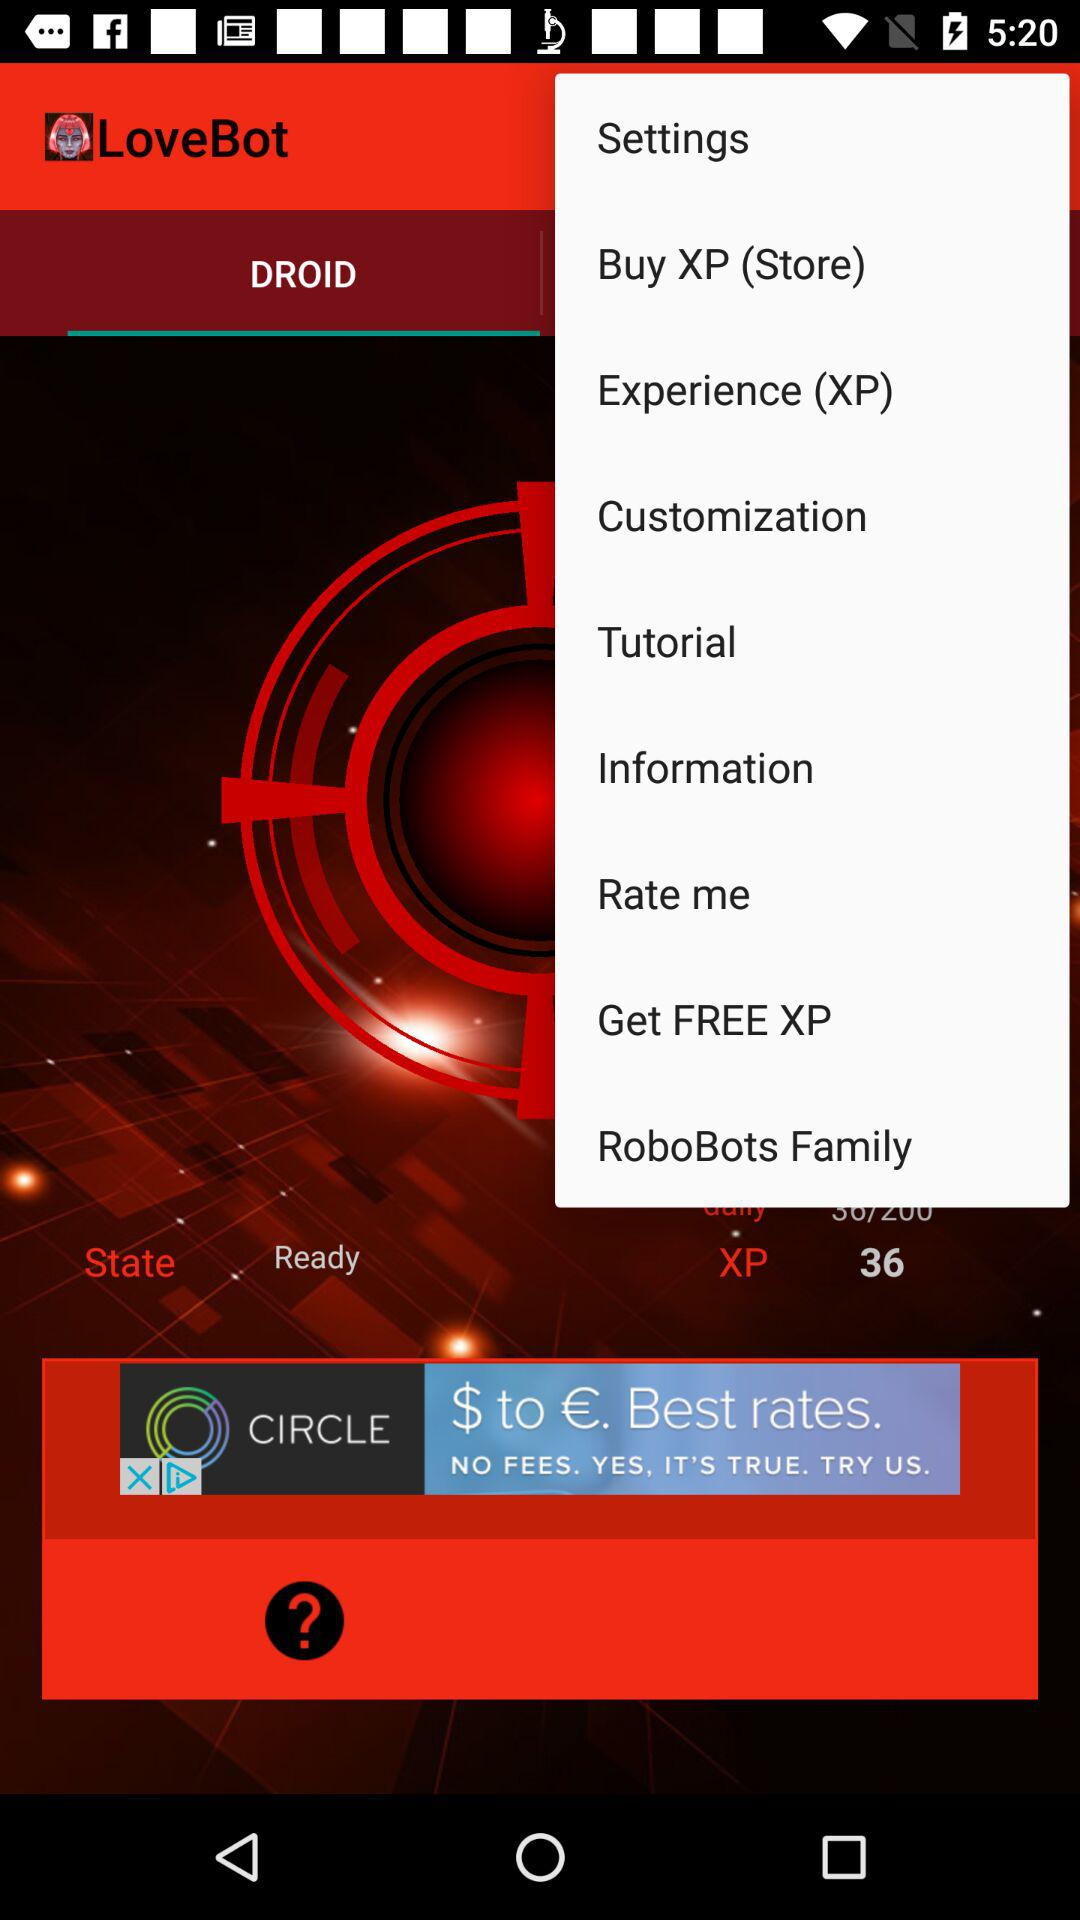What is the application name? The application name is "LoveBot". 